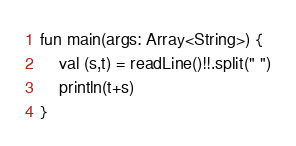<code> <loc_0><loc_0><loc_500><loc_500><_Kotlin_>fun main(args: Array<String>) {
    val (s,t) = readLine()!!.split(" ")
    println(t+s)
}</code> 